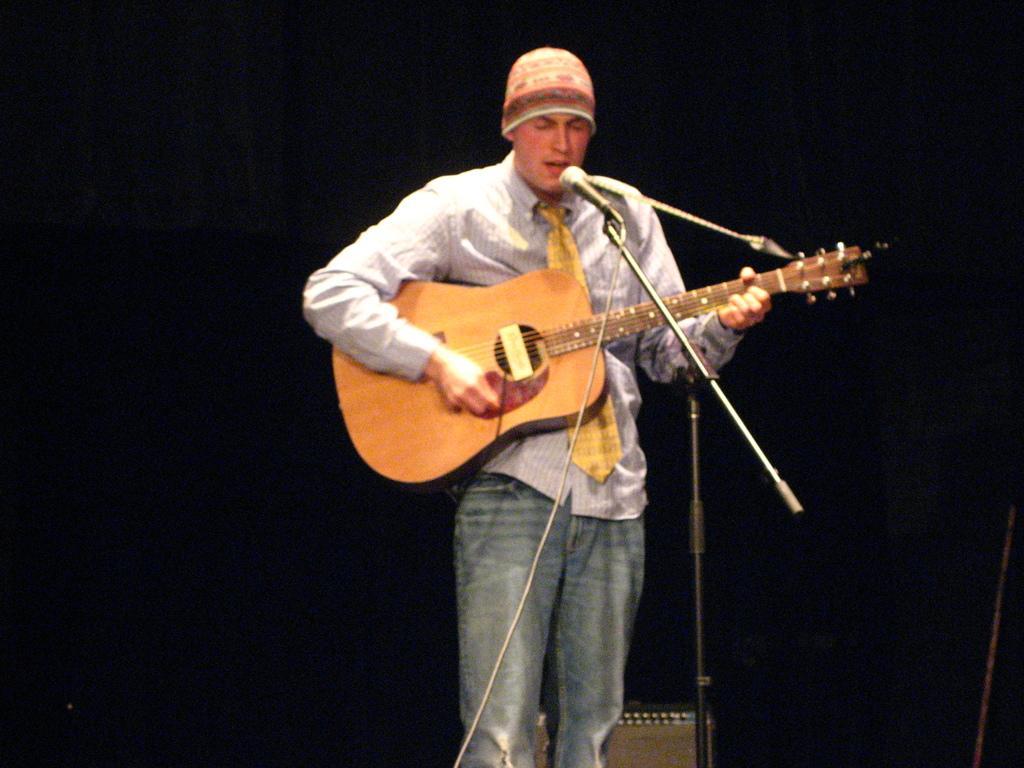Please provide a concise description of this image. In the center we can see one person standing and holding guitar. In front there is a microphone. 